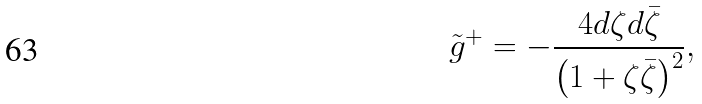<formula> <loc_0><loc_0><loc_500><loc_500>\tilde { g } ^ { + } = - \frac { 4 d \zeta d \bar { \zeta } } { \left ( 1 + \zeta \bar { \zeta } \right ) ^ { 2 } } ,</formula> 